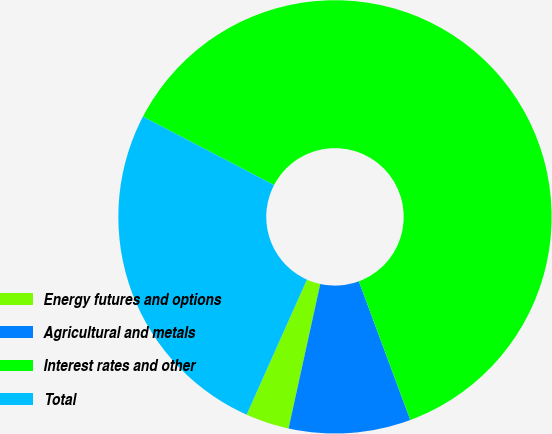Convert chart. <chart><loc_0><loc_0><loc_500><loc_500><pie_chart><fcel>Energy futures and options<fcel>Agricultural and metals<fcel>Interest rates and other<fcel>Total<nl><fcel>3.25%<fcel>9.09%<fcel>61.69%<fcel>25.97%<nl></chart> 